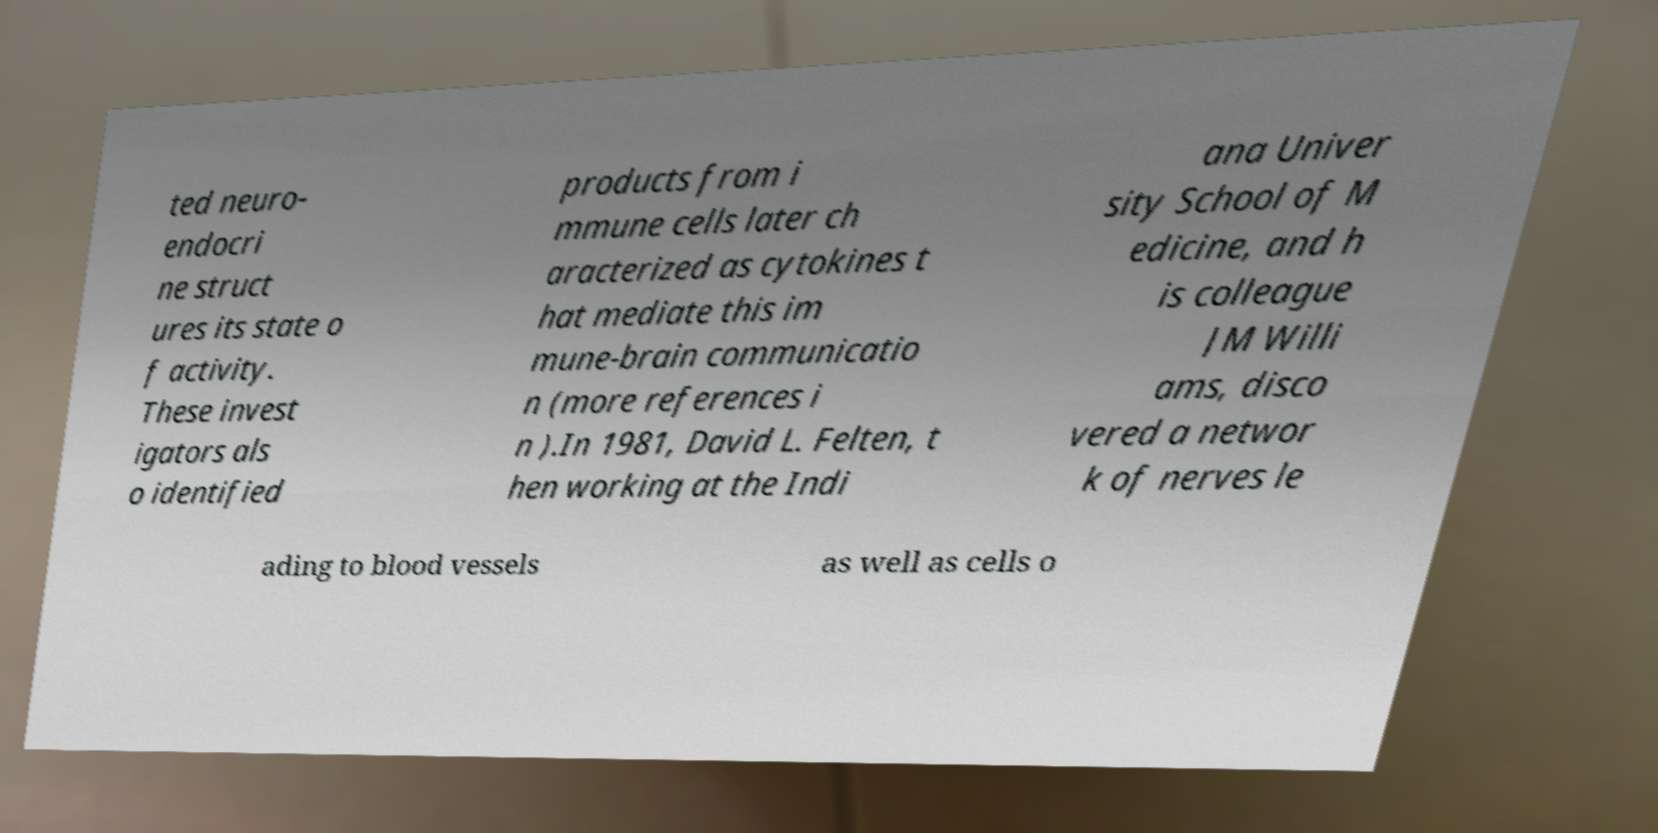Could you assist in decoding the text presented in this image and type it out clearly? ted neuro- endocri ne struct ures its state o f activity. These invest igators als o identified products from i mmune cells later ch aracterized as cytokines t hat mediate this im mune-brain communicatio n (more references i n ).In 1981, David L. Felten, t hen working at the Indi ana Univer sity School of M edicine, and h is colleague JM Willi ams, disco vered a networ k of nerves le ading to blood vessels as well as cells o 